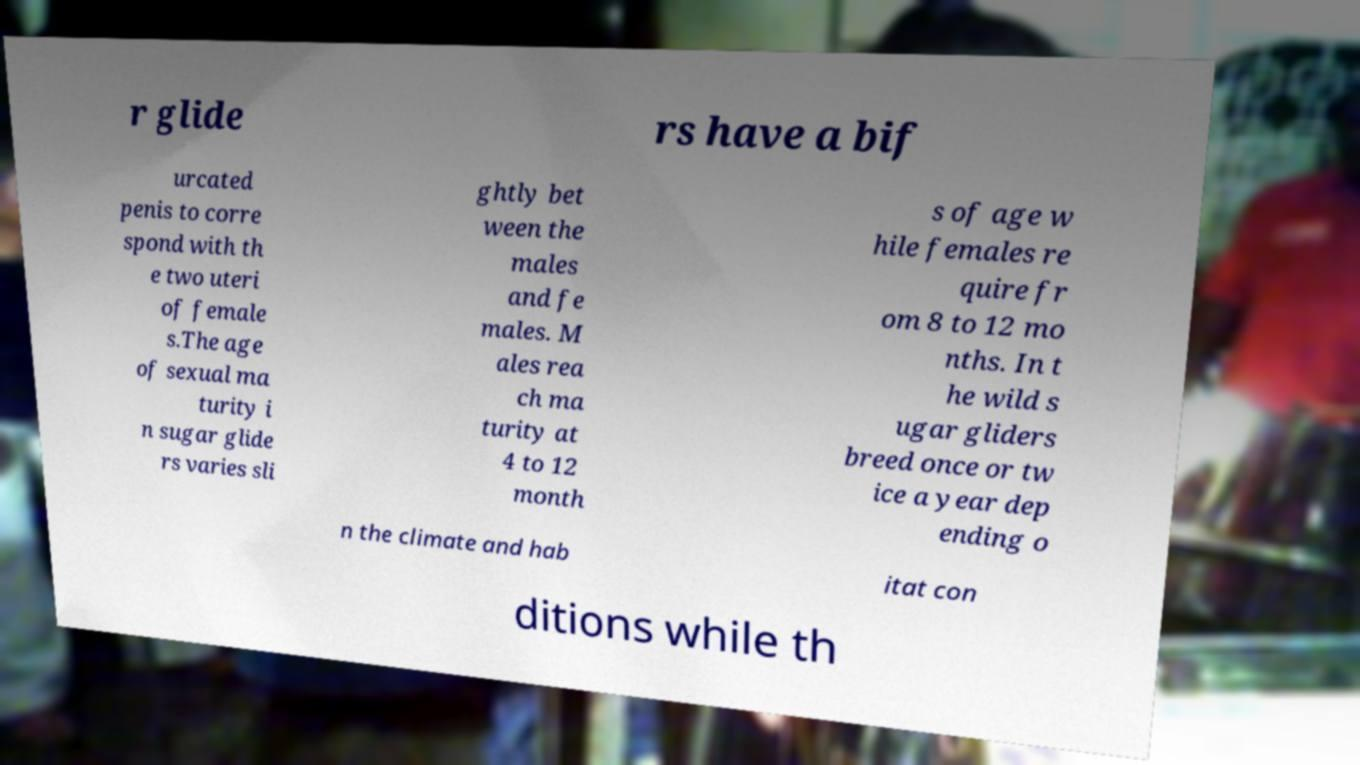For documentation purposes, I need the text within this image transcribed. Could you provide that? r glide rs have a bif urcated penis to corre spond with th e two uteri of female s.The age of sexual ma turity i n sugar glide rs varies sli ghtly bet ween the males and fe males. M ales rea ch ma turity at 4 to 12 month s of age w hile females re quire fr om 8 to 12 mo nths. In t he wild s ugar gliders breed once or tw ice a year dep ending o n the climate and hab itat con ditions while th 